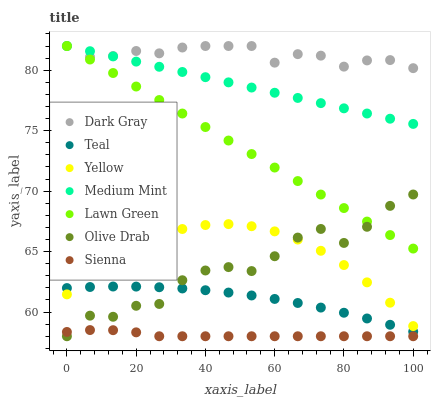Does Sienna have the minimum area under the curve?
Answer yes or no. Yes. Does Dark Gray have the maximum area under the curve?
Answer yes or no. Yes. Does Lawn Green have the minimum area under the curve?
Answer yes or no. No. Does Lawn Green have the maximum area under the curve?
Answer yes or no. No. Is Lawn Green the smoothest?
Answer yes or no. Yes. Is Olive Drab the roughest?
Answer yes or no. Yes. Is Yellow the smoothest?
Answer yes or no. No. Is Yellow the roughest?
Answer yes or no. No. Does Sienna have the lowest value?
Answer yes or no. Yes. Does Lawn Green have the lowest value?
Answer yes or no. No. Does Dark Gray have the highest value?
Answer yes or no. Yes. Does Yellow have the highest value?
Answer yes or no. No. Is Yellow less than Dark Gray?
Answer yes or no. Yes. Is Dark Gray greater than Sienna?
Answer yes or no. Yes. Does Lawn Green intersect Olive Drab?
Answer yes or no. Yes. Is Lawn Green less than Olive Drab?
Answer yes or no. No. Is Lawn Green greater than Olive Drab?
Answer yes or no. No. Does Yellow intersect Dark Gray?
Answer yes or no. No. 